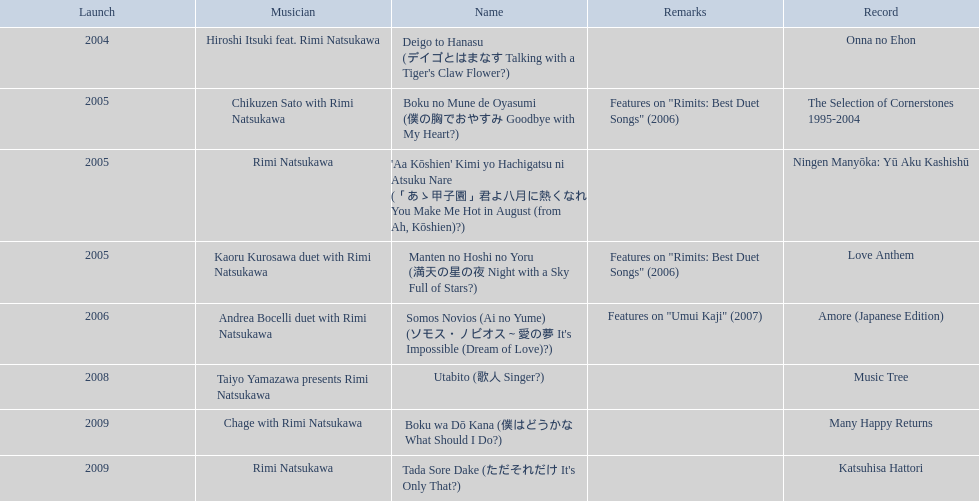What are the names of each album by rimi natsukawa? Onna no Ehon, The Selection of Cornerstones 1995-2004, Ningen Manyōka: Yū Aku Kashishū, Love Anthem, Amore (Japanese Edition), Music Tree, Many Happy Returns, Katsuhisa Hattori. And when were the albums released? 2004, 2005, 2005, 2005, 2006, 2008, 2009, 2009. Was onna no ehon or music tree released most recently? Music Tree. 